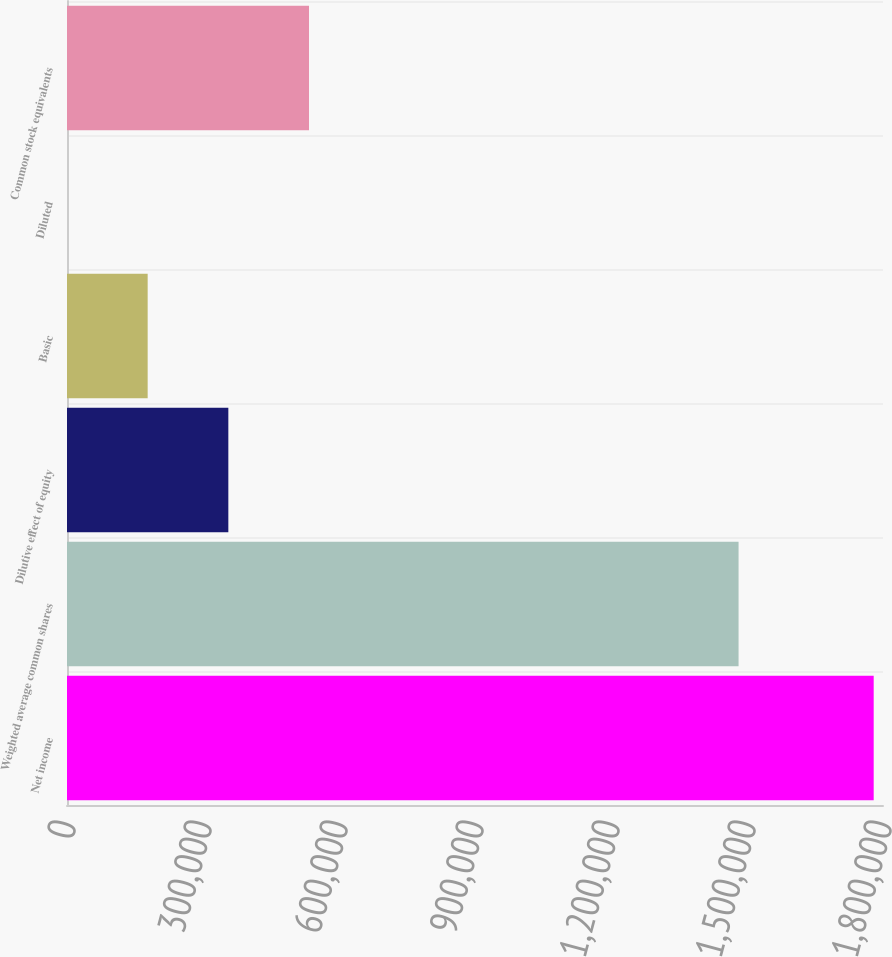Convert chart. <chart><loc_0><loc_0><loc_500><loc_500><bar_chart><fcel>Net income<fcel>Weighted average common shares<fcel>Dilutive effect of equity<fcel>Basic<fcel>Diluted<fcel>Common stock equivalents<nl><fcel>1.77947e+06<fcel>1.4814e+06<fcel>355896<fcel>177949<fcel>1.36<fcel>533843<nl></chart> 